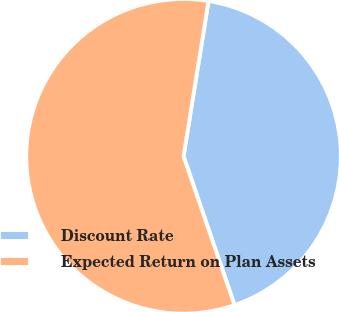<chart> <loc_0><loc_0><loc_500><loc_500><pie_chart><fcel>Discount Rate<fcel>Expected Return on Plan Assets<nl><fcel>42.21%<fcel>57.79%<nl></chart> 